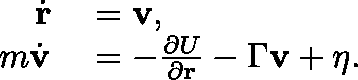<formula> <loc_0><loc_0><loc_500><loc_500>\begin{array} { r l } { \dot { r } } & = v , } \\ { m \dot { v } } & = - \frac { \partial U } { \partial r } - \Gamma v + \eta . } \end{array}</formula> 